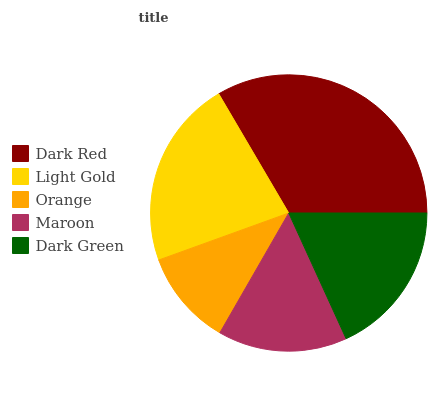Is Orange the minimum?
Answer yes or no. Yes. Is Dark Red the maximum?
Answer yes or no. Yes. Is Light Gold the minimum?
Answer yes or no. No. Is Light Gold the maximum?
Answer yes or no. No. Is Dark Red greater than Light Gold?
Answer yes or no. Yes. Is Light Gold less than Dark Red?
Answer yes or no. Yes. Is Light Gold greater than Dark Red?
Answer yes or no. No. Is Dark Red less than Light Gold?
Answer yes or no. No. Is Dark Green the high median?
Answer yes or no. Yes. Is Dark Green the low median?
Answer yes or no. Yes. Is Light Gold the high median?
Answer yes or no. No. Is Maroon the low median?
Answer yes or no. No. 